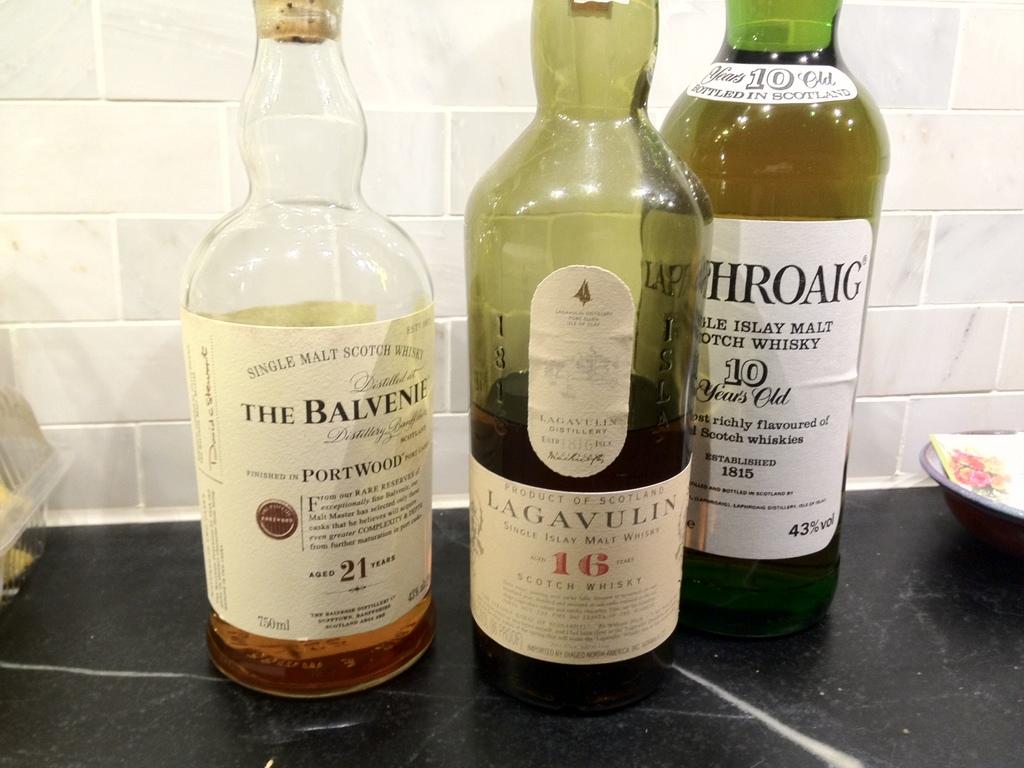How old is the youngest whisky bottle?
Make the answer very short. 10 years. How many bottles are on the table?
Provide a short and direct response. Answering does not require reading text in the image. 